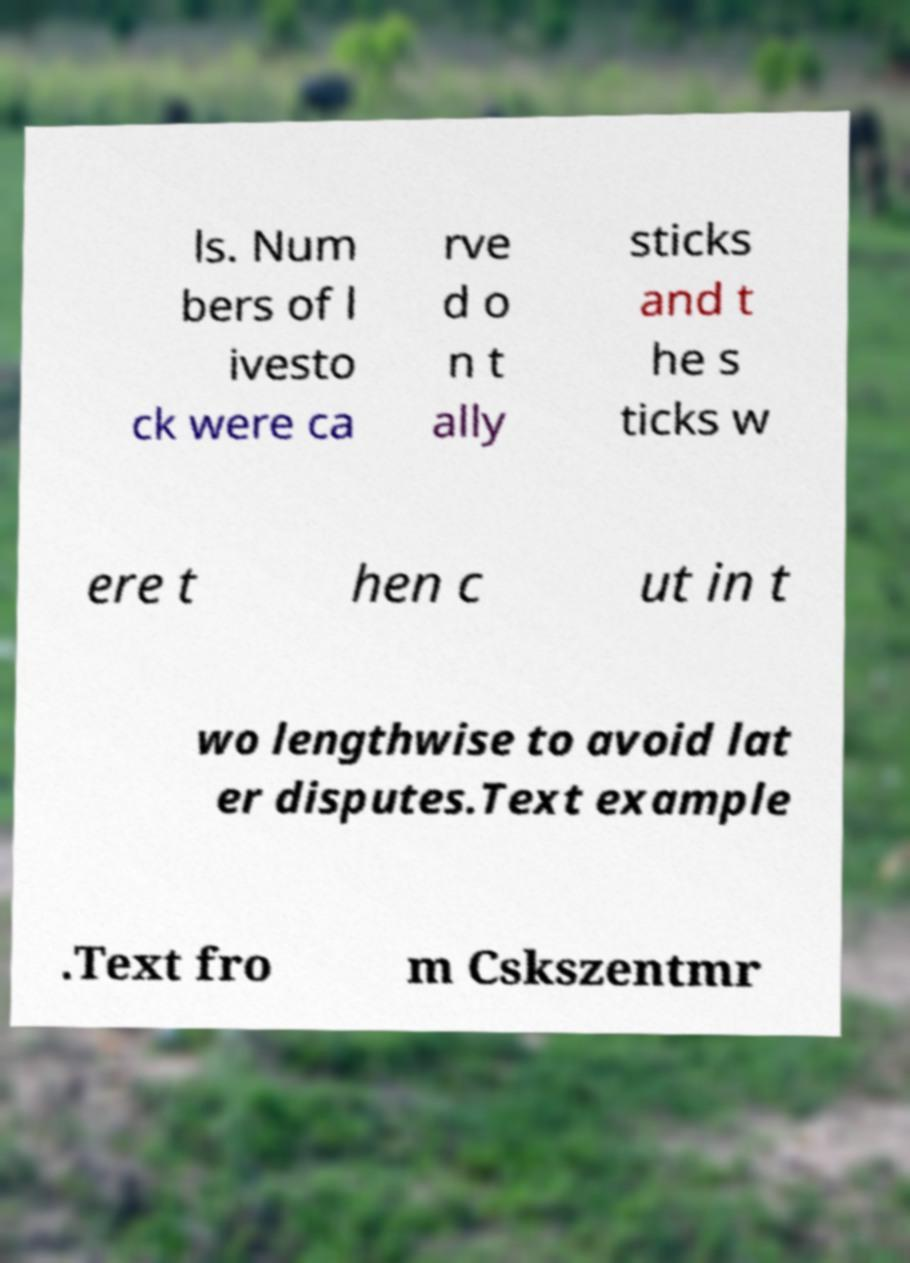I need the written content from this picture converted into text. Can you do that? ls. Num bers of l ivesto ck were ca rve d o n t ally sticks and t he s ticks w ere t hen c ut in t wo lengthwise to avoid lat er disputes.Text example .Text fro m Cskszentmr 